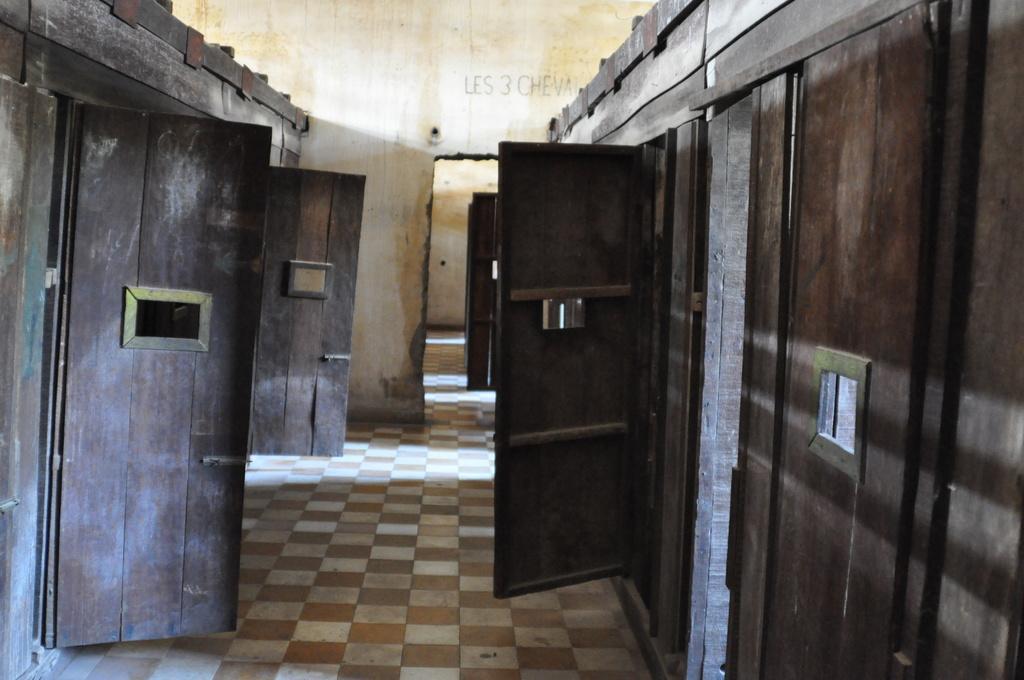Describe this image in one or two sentences. In this image I can see the interior of the building in which I can see the floor, few brown colored doors and the wall which is cream and yellow in color. 